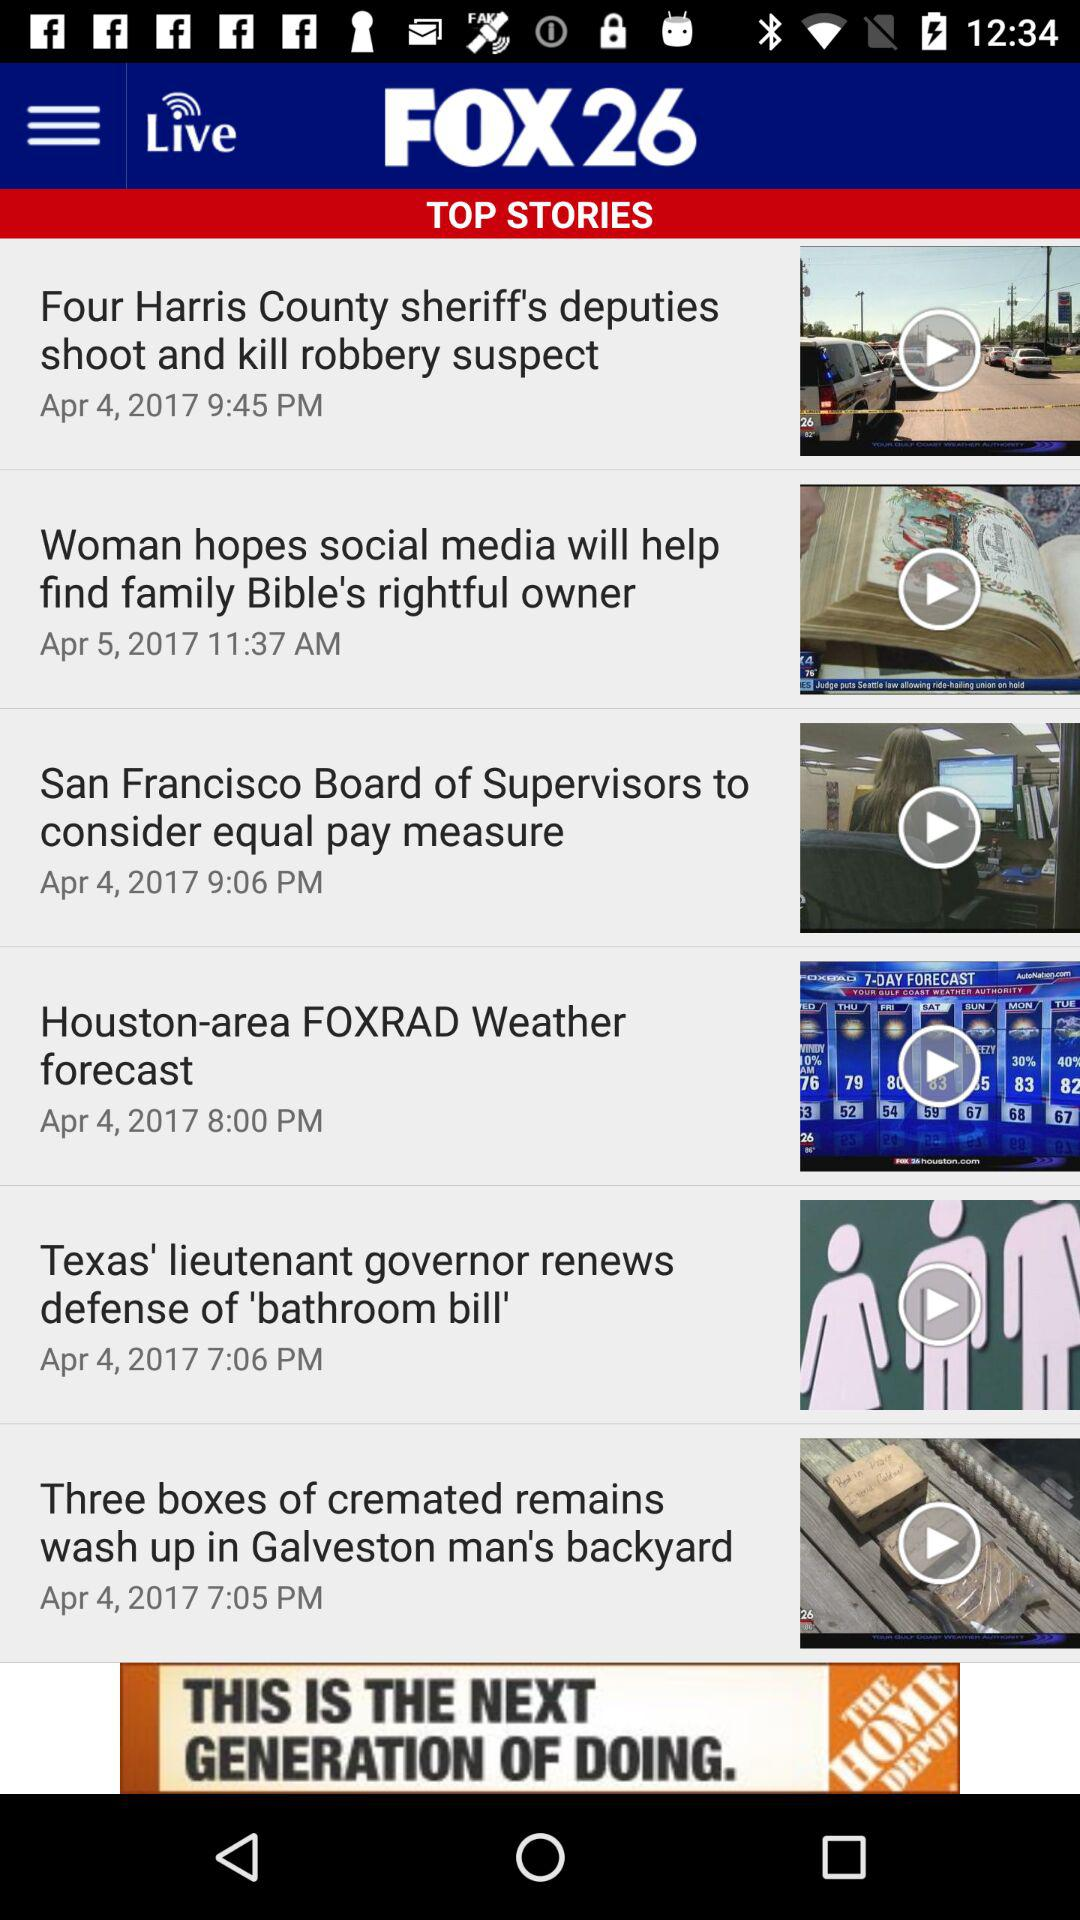What is the posted time for the "San Francisco Board of Supervisors to consider equal pay measure"? The time is 9:06 pm. 